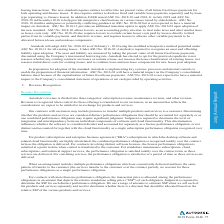According to Autodesk's financial document, What revenue does Autodesk recognize? Based on the financial document, the answer is Autodesk recognizes revenue from the sale of (1) product subscriptions, cloud service offerings, and flexible enterprise business agreements ("EBAs"), (2) renewal fees for existing maintenance plan agreements that were initially purchased with a perpetual software license, and (3) consulting, training and other goods and services.. Also, What was the 2017 revenue from manufacturing? Based on the financial document, the answer is 528.8 (in millions). Also, What are the payment terms for product subscriptions, industry collections, cloud subscriptions, and maintenance subscriptions? Based on the financial document, the answer is 30 to 45 days. Also, can you calculate: What percentage of total net revenue in 2019 came from the US? Based on the calculation: 874.6/2,569.8, the result is 34.03 (percentage). The key data points involved are: 2,569.8, 874.6. Also, can you calculate: What is the change in total net revenue from 2019 to 2018? Based on the calculation: 2,569.8-2,056.6, the result is 513.2 (in millions). The key data points involved are: 2,056.6, 2,569.8. Also, can you calculate: What is the total revenue from Manufacturing from 2018 to 2019?  Based on the calculation: 528.8+616.2 , the result is 1145 (in millions). The key data points involved are: 528.8, 616.2. 